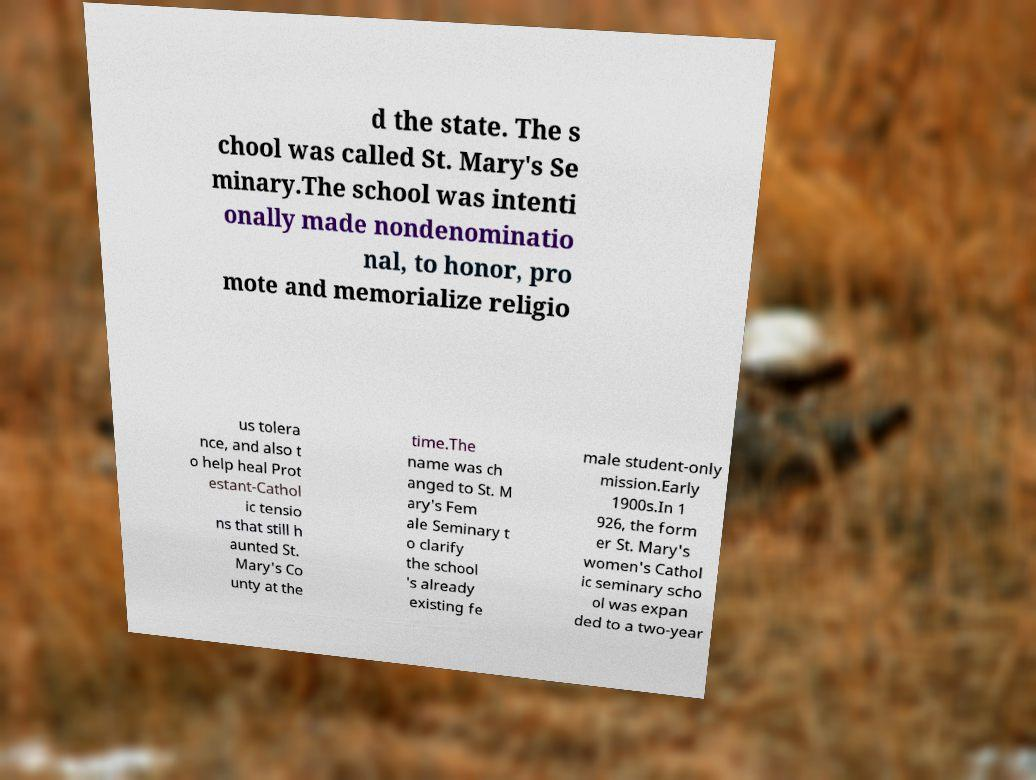There's text embedded in this image that I need extracted. Can you transcribe it verbatim? d the state. The s chool was called St. Mary's Se minary.The school was intenti onally made nondenominatio nal, to honor, pro mote and memorialize religio us tolera nce, and also t o help heal Prot estant-Cathol ic tensio ns that still h aunted St. Mary's Co unty at the time.The name was ch anged to St. M ary's Fem ale Seminary t o clarify the school 's already existing fe male student-only mission.Early 1900s.In 1 926, the form er St. Mary's women's Cathol ic seminary scho ol was expan ded to a two-year 